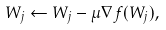Convert formula to latex. <formula><loc_0><loc_0><loc_500><loc_500>W _ { j } \leftarrow W _ { j } - \mu \nabla f ( W _ { j } ) ,</formula> 